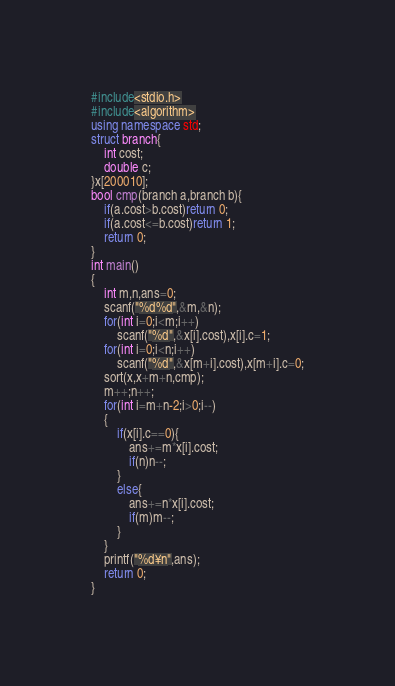<code> <loc_0><loc_0><loc_500><loc_500><_C++_>#include<stdio.h>
#include<algorithm>
using namespace std;
struct branch{
	int cost;
	double c;
}x[200010];
bool cmp(branch a,branch b){
	if(a.cost>b.cost)return 0;
	if(a.cost<=b.cost)return 1;
	return 0;
}
int main()
{
	int m,n,ans=0;
	scanf("%d%d",&m,&n);
	for(int i=0;i<m;i++)
		scanf("%d",&x[i].cost),x[i].c=1;
	for(int i=0;i<n;i++)
		scanf("%d",&x[m+i].cost),x[m+i].c=0;
	sort(x,x+m+n,cmp);
	m++;n++;
	for(int i=m+n-2;i>0;i--)
	{
		if(x[i].c==0){
			ans+=m*x[i].cost;
			if(n)n--;
		}
		else{
			ans+=n*x[i].cost;
			if(m)m--;
		}
	}
	printf("%d¥n",ans);
	return 0;
}
</code> 